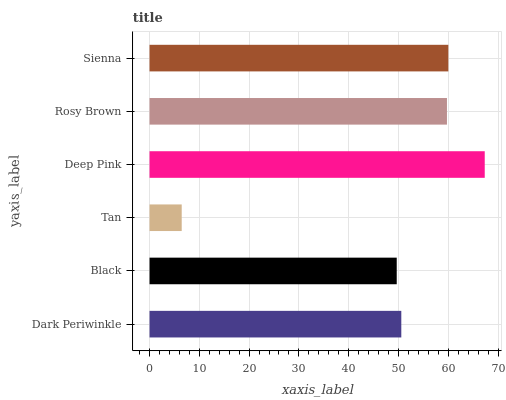Is Tan the minimum?
Answer yes or no. Yes. Is Deep Pink the maximum?
Answer yes or no. Yes. Is Black the minimum?
Answer yes or no. No. Is Black the maximum?
Answer yes or no. No. Is Dark Periwinkle greater than Black?
Answer yes or no. Yes. Is Black less than Dark Periwinkle?
Answer yes or no. Yes. Is Black greater than Dark Periwinkle?
Answer yes or no. No. Is Dark Periwinkle less than Black?
Answer yes or no. No. Is Rosy Brown the high median?
Answer yes or no. Yes. Is Dark Periwinkle the low median?
Answer yes or no. Yes. Is Deep Pink the high median?
Answer yes or no. No. Is Deep Pink the low median?
Answer yes or no. No. 